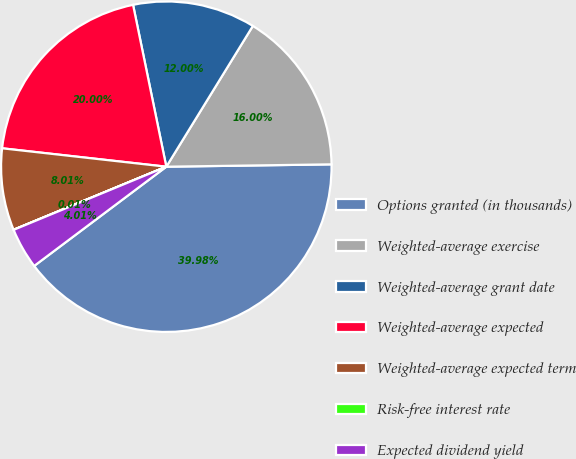<chart> <loc_0><loc_0><loc_500><loc_500><pie_chart><fcel>Options granted (in thousands)<fcel>Weighted-average exercise<fcel>Weighted-average grant date<fcel>Weighted-average expected<fcel>Weighted-average expected term<fcel>Risk-free interest rate<fcel>Expected dividend yield<nl><fcel>39.98%<fcel>16.0%<fcel>12.0%<fcel>20.0%<fcel>8.01%<fcel>0.01%<fcel>4.01%<nl></chart> 